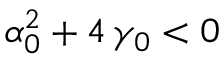<formula> <loc_0><loc_0><loc_500><loc_500>\alpha _ { 0 } ^ { 2 } + 4 \, \gamma _ { 0 } < 0</formula> 